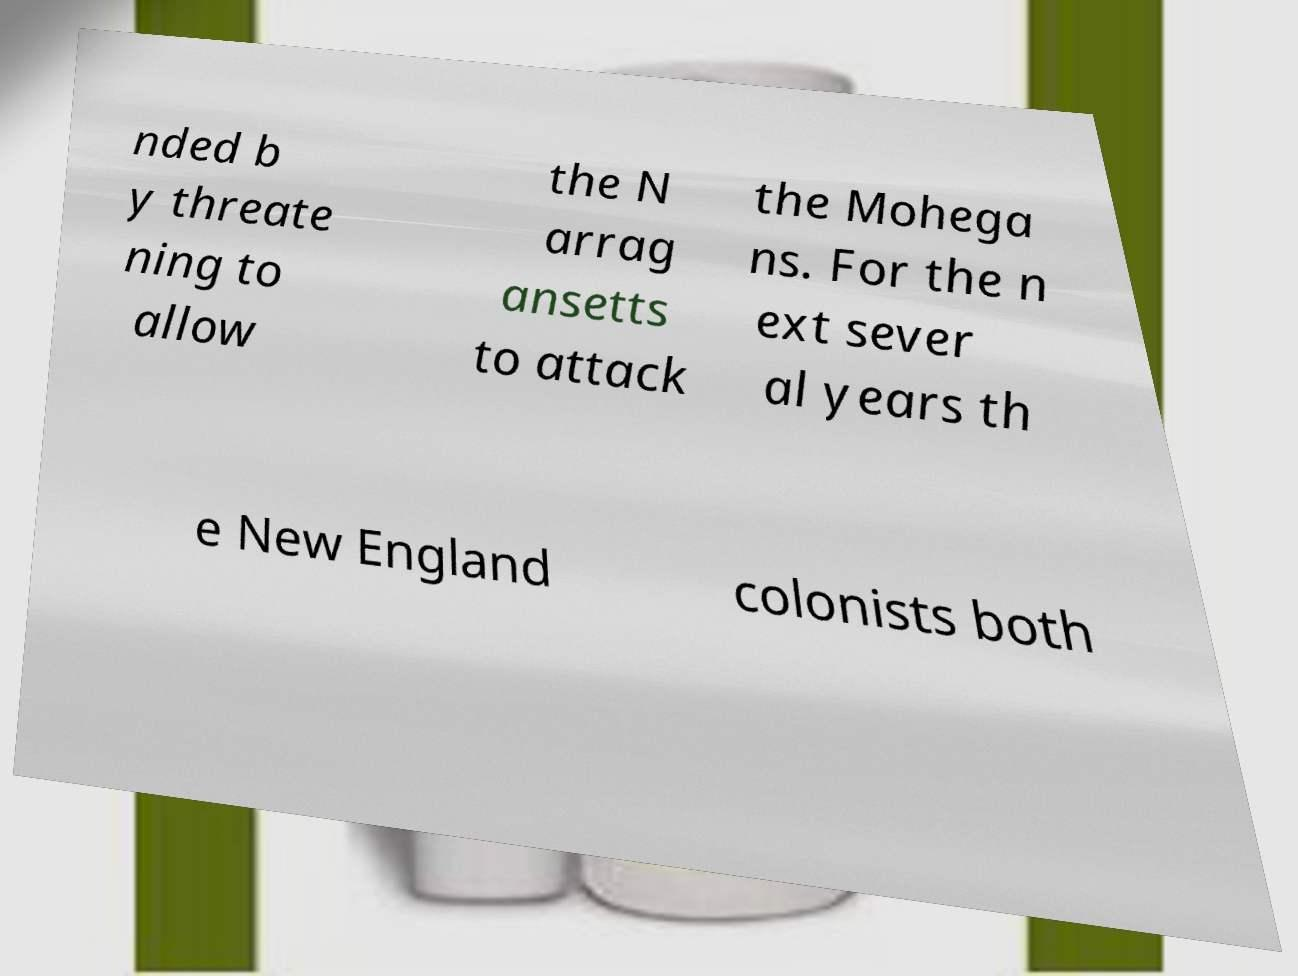I need the written content from this picture converted into text. Can you do that? nded b y threate ning to allow the N arrag ansetts to attack the Mohega ns. For the n ext sever al years th e New England colonists both 